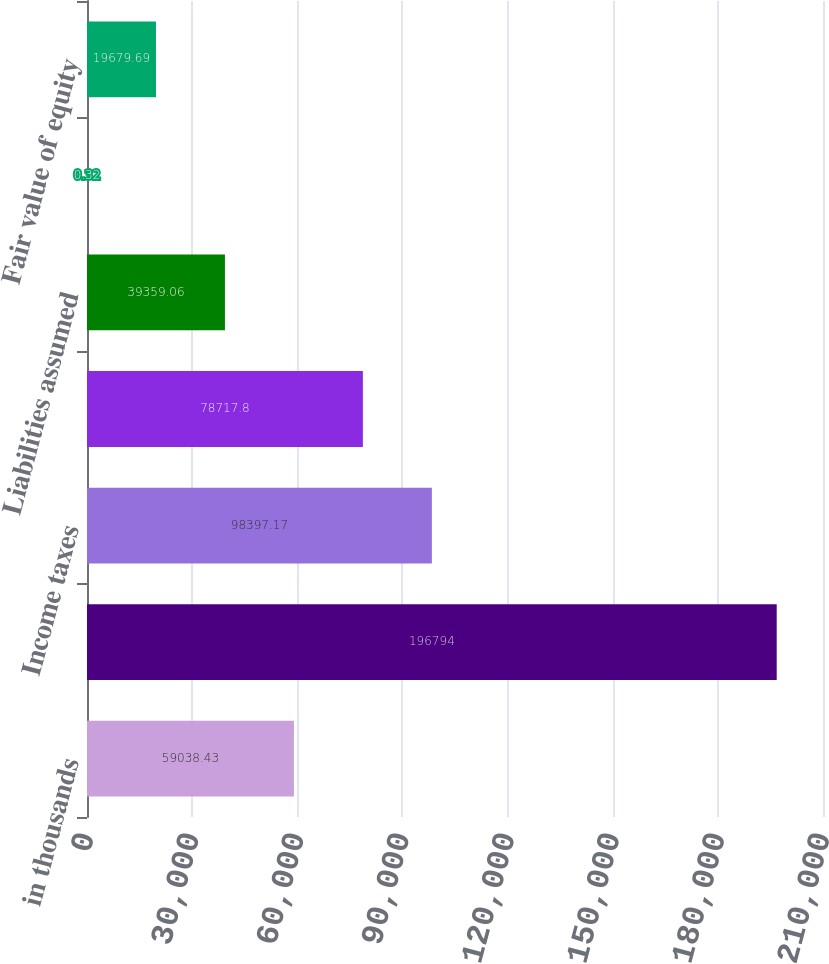<chart> <loc_0><loc_0><loc_500><loc_500><bar_chart><fcel>in thousands<fcel>Interest (exclusive of amount<fcel>Income taxes<fcel>plant & equipment<fcel>Liabilities assumed<fcel>Fair value of noncash assets<fcel>Fair value of equity<nl><fcel>59038.4<fcel>196794<fcel>98397.2<fcel>78717.8<fcel>39359.1<fcel>0.32<fcel>19679.7<nl></chart> 